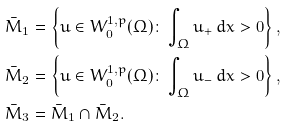Convert formula to latex. <formula><loc_0><loc_0><loc_500><loc_500>& \bar { M } _ { 1 } = \left \{ u \in W ^ { 1 , p } _ { 0 } ( \Omega ) \colon \int _ { \Omega } u _ { + } \, d x > 0 \right \} , \\ & \bar { M } _ { 2 } = \left \{ u \in W ^ { 1 , p } _ { 0 } ( \Omega ) \colon \int _ { \Omega } u _ { - } \, d x > 0 \right \} , \\ & \bar { M } _ { 3 } = \bar { M } _ { 1 } \cap \bar { M } _ { 2 } .</formula> 